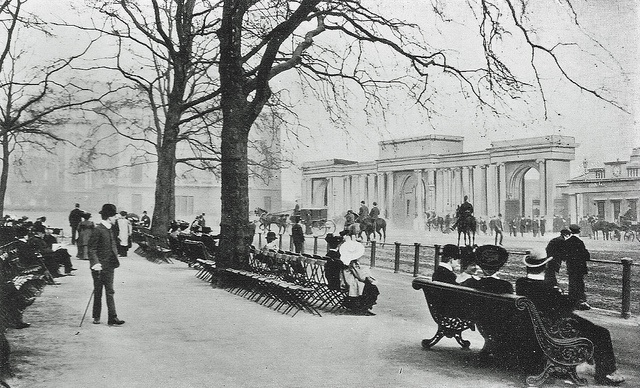Describe the objects in this image and their specific colors. I can see people in darkgray, black, gray, and lightgray tones, bench in lightgray, black, gray, and darkgray tones, bench in lightgray, black, gray, and darkgray tones, people in lightgray, black, gray, and darkgray tones, and people in lightgray, black, darkgray, and gray tones in this image. 